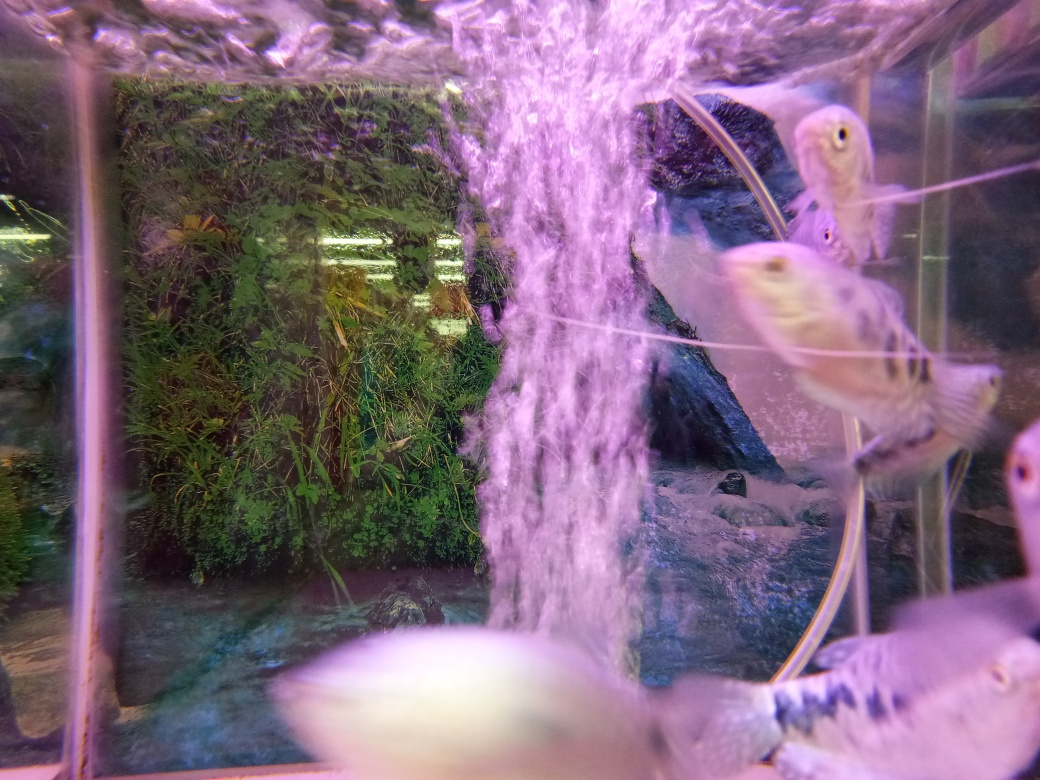How would you describe the colors in the image? A. Faded B. Dull C. Rich The colors in the image can be described as a blend of vibrancy and subtlety. While the overall color palette is not overly saturated, the shades within the aquarium exhibit a natural richness. The green aquatic plants provide a lively backdrop, contrasting with the dynamic purples and pinks created by the bubbling water. The fish possess delicate colorations that are subtle yet detailed, contributing to an image that is harmonious and rich in aquatic tones. 